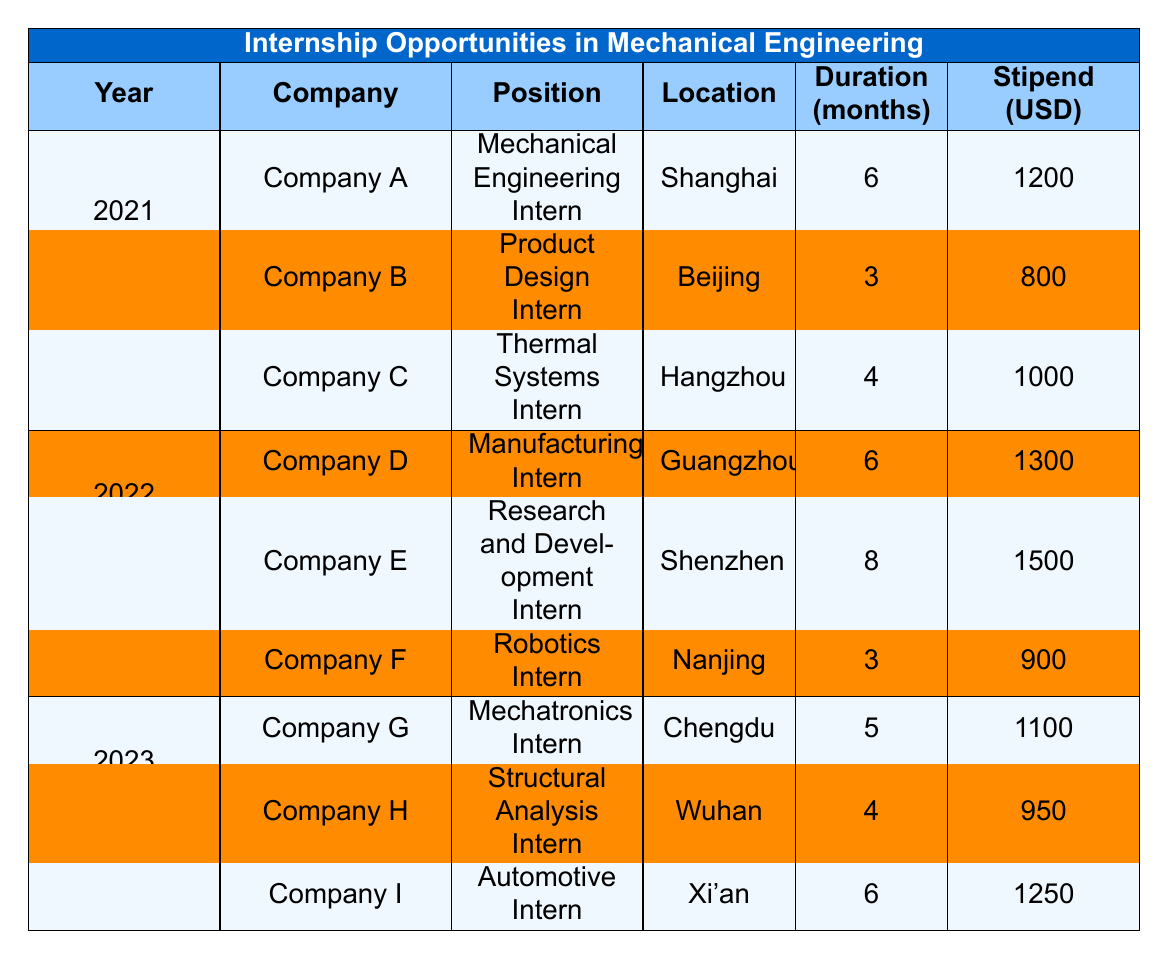What internship position was offered by Company A in 2021? The table shows that for the year 2021, Company A offered the position of "Mechanical Engineering Intern."
Answer: Mechanical Engineering Intern Which company provided a stipend of 1500 USD in 2022? In the table for 2022, Company E is indicated as providing a stipend of 1500 USD for the position of "Research and Development Intern."
Answer: Company E How long was the internship period at Company C? According to the table, Company C had an internship duration of 4 months in 2021.
Answer: 4 months What is the total stipend offered by Company D and Company E? The stipends for Company D and Company E are 1300 USD and 1500 USD respectively. Adding these gives 1300 + 1500 = 2800 USD.
Answer: 2800 USD Did Company H offer an internship with a stipend greater than 1000 USD? The stipend for Company H is listed as 950 USD, which is not greater than 1000 USD.
Answer: No What was the average stipend offered for internships in 2023? The stipends for 2023 are 1100 USD (Company G), 950 USD (Company H), and 1250 USD (Company I). Summing these gives 1100 + 950 + 1250 = 3300 USD. There are 3 internships; thus, the average is 3300 / 3 = 1100 USD.
Answer: 1100 USD Which location had the highest stipend in 2022, and what was the amount? Reviewing the stipends for 2022, Company E in Shenzhen offers the highest stipend of 1500 USD, higher than Company D and Company F.
Answer: Shenzhen, 1500 USD For which company in 2023 was the internship duration equal to 6 months? Company I offers an internship duration of 6 months in 2023, while the other companies listed offer durations of 5 months and 4 months.
Answer: Company I What is the difference in duration between the longest and shortest internship offered in 2021? In 2021, Company A offered 6 months, Company B offered 3 months, and Company C offered 4 months. The difference between the longest (6 months) and shortest (3 months) is 6 - 3 = 3 months.
Answer: 3 months Is there any internship in 2022 that has a shorter duration than 3 months? Analyzing the durations for 2022, Company D has an internship of 6 months, Company E has 8 months, and Company F has 3 months, indicating that none are shorter than 3 months.
Answer: No 